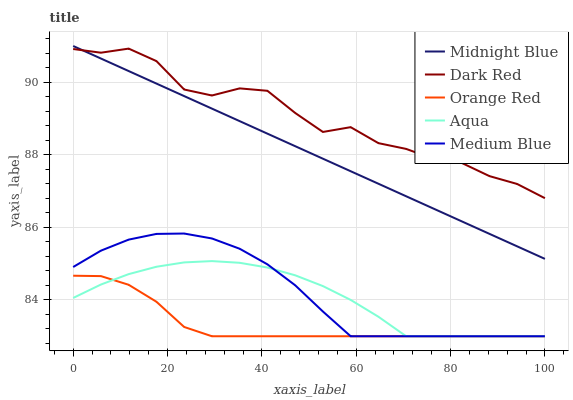Does Orange Red have the minimum area under the curve?
Answer yes or no. Yes. Does Dark Red have the maximum area under the curve?
Answer yes or no. Yes. Does Aqua have the minimum area under the curve?
Answer yes or no. No. Does Aqua have the maximum area under the curve?
Answer yes or no. No. Is Midnight Blue the smoothest?
Answer yes or no. Yes. Is Dark Red the roughest?
Answer yes or no. Yes. Is Aqua the smoothest?
Answer yes or no. No. Is Aqua the roughest?
Answer yes or no. No. Does Medium Blue have the lowest value?
Answer yes or no. Yes. Does Dark Red have the lowest value?
Answer yes or no. No. Does Midnight Blue have the highest value?
Answer yes or no. Yes. Does Dark Red have the highest value?
Answer yes or no. No. Is Aqua less than Midnight Blue?
Answer yes or no. Yes. Is Midnight Blue greater than Medium Blue?
Answer yes or no. Yes. Does Medium Blue intersect Orange Red?
Answer yes or no. Yes. Is Medium Blue less than Orange Red?
Answer yes or no. No. Is Medium Blue greater than Orange Red?
Answer yes or no. No. Does Aqua intersect Midnight Blue?
Answer yes or no. No. 